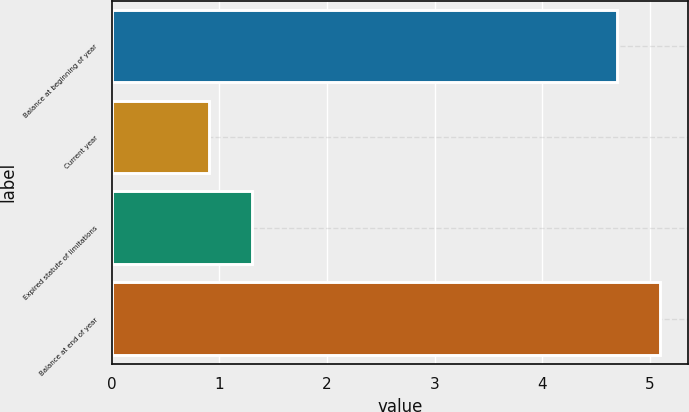Convert chart to OTSL. <chart><loc_0><loc_0><loc_500><loc_500><bar_chart><fcel>Balance at beginning of year<fcel>Current year<fcel>Expired statute of limitations<fcel>Balance at end of year<nl><fcel>4.7<fcel>0.9<fcel>1.3<fcel>5.1<nl></chart> 